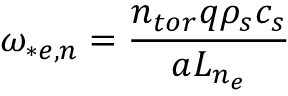Convert formula to latex. <formula><loc_0><loc_0><loc_500><loc_500>\omega _ { * e , n } = \frac { n _ { t o r } q \rho _ { s } c _ { s } } { a L _ { n _ { e } } }</formula> 